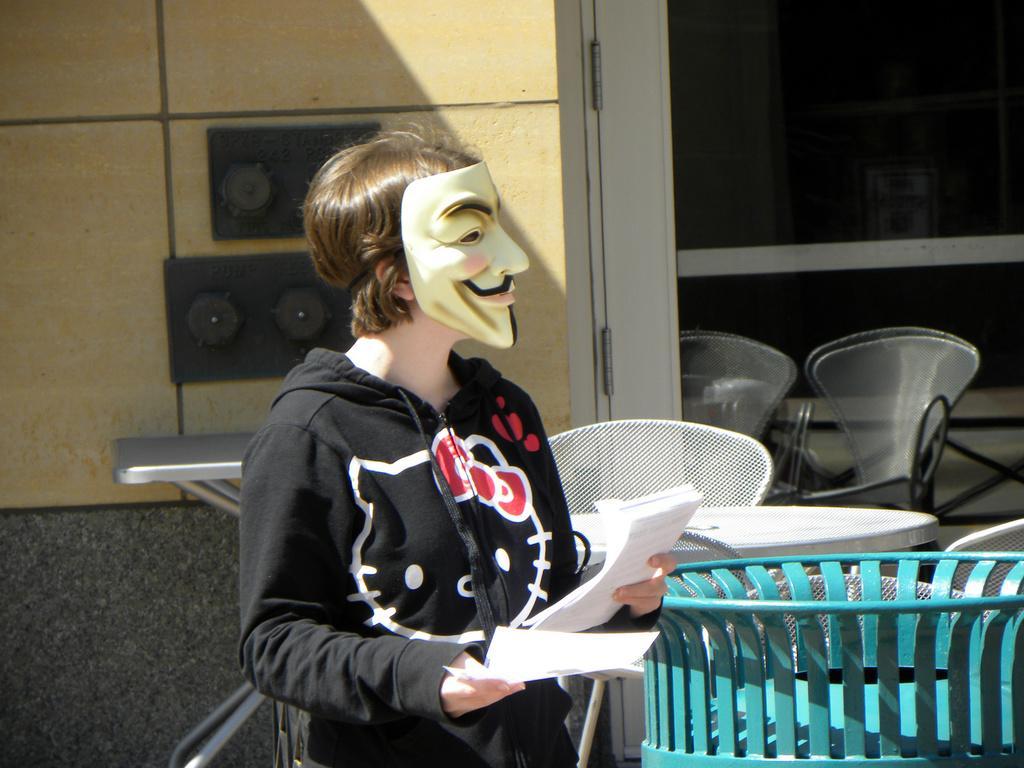How would you summarize this image in a sentence or two? In the picture we can see a woman standing near the table, she is wearing a black color hoodie with some designs on it and she is also wearing a mask to the face and in front of her we can see some chairs and tables and behind her we can see a wall with some music boxes in it. 